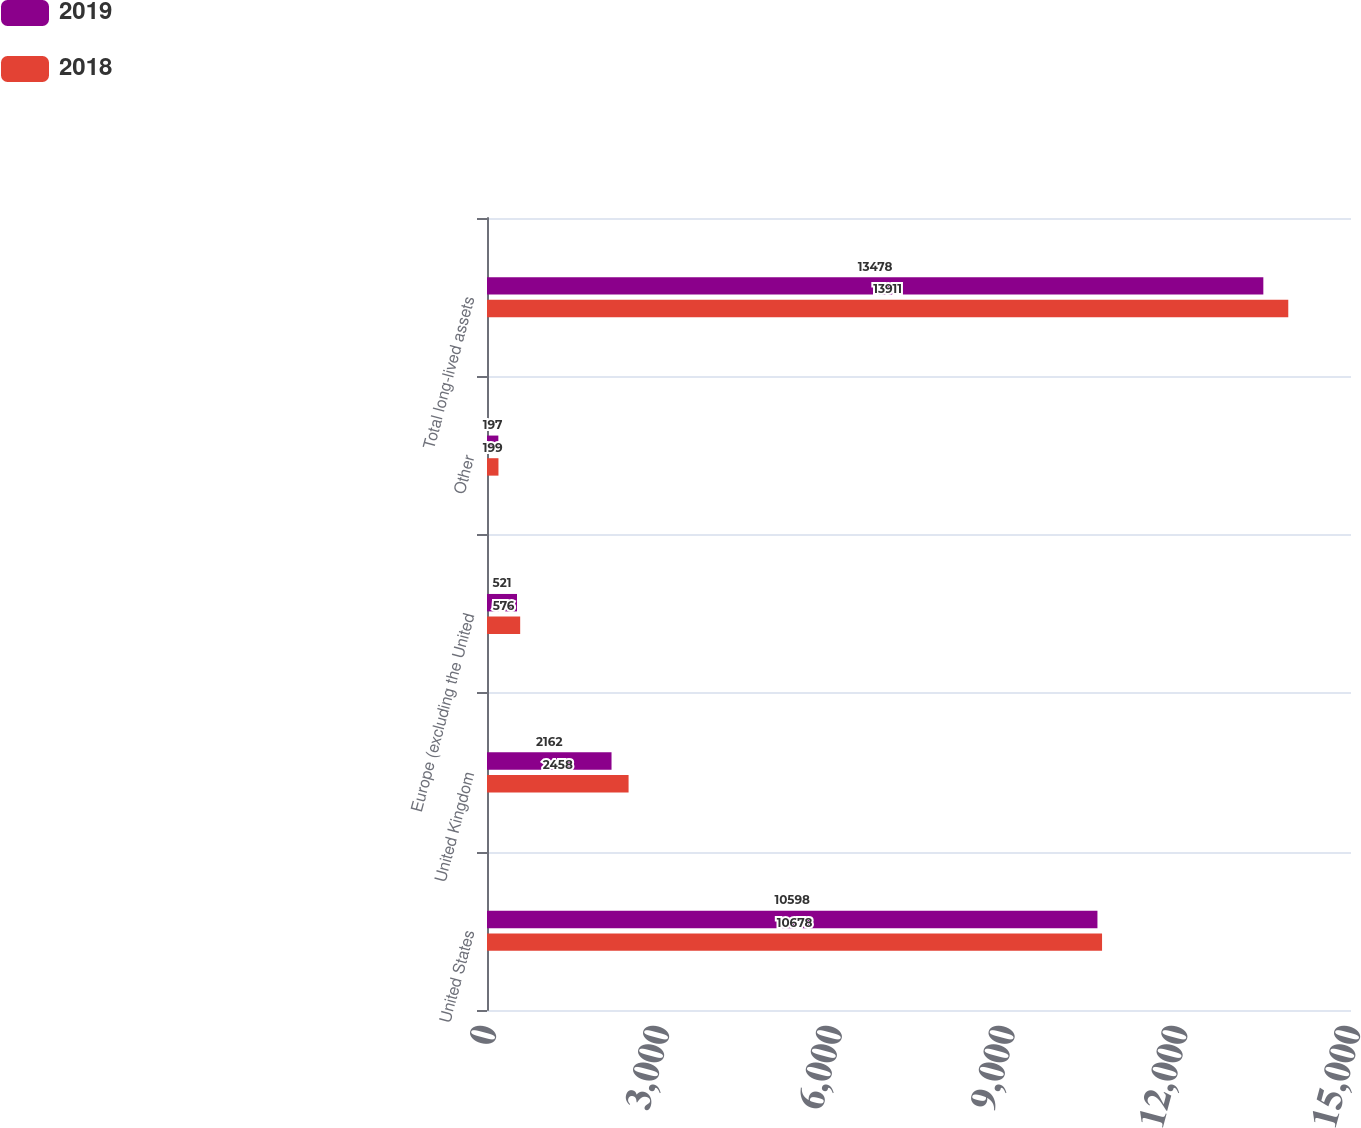Convert chart. <chart><loc_0><loc_0><loc_500><loc_500><stacked_bar_chart><ecel><fcel>United States<fcel>United Kingdom<fcel>Europe (excluding the United<fcel>Other<fcel>Total long-lived assets<nl><fcel>2019<fcel>10598<fcel>2162<fcel>521<fcel>197<fcel>13478<nl><fcel>2018<fcel>10678<fcel>2458<fcel>576<fcel>199<fcel>13911<nl></chart> 